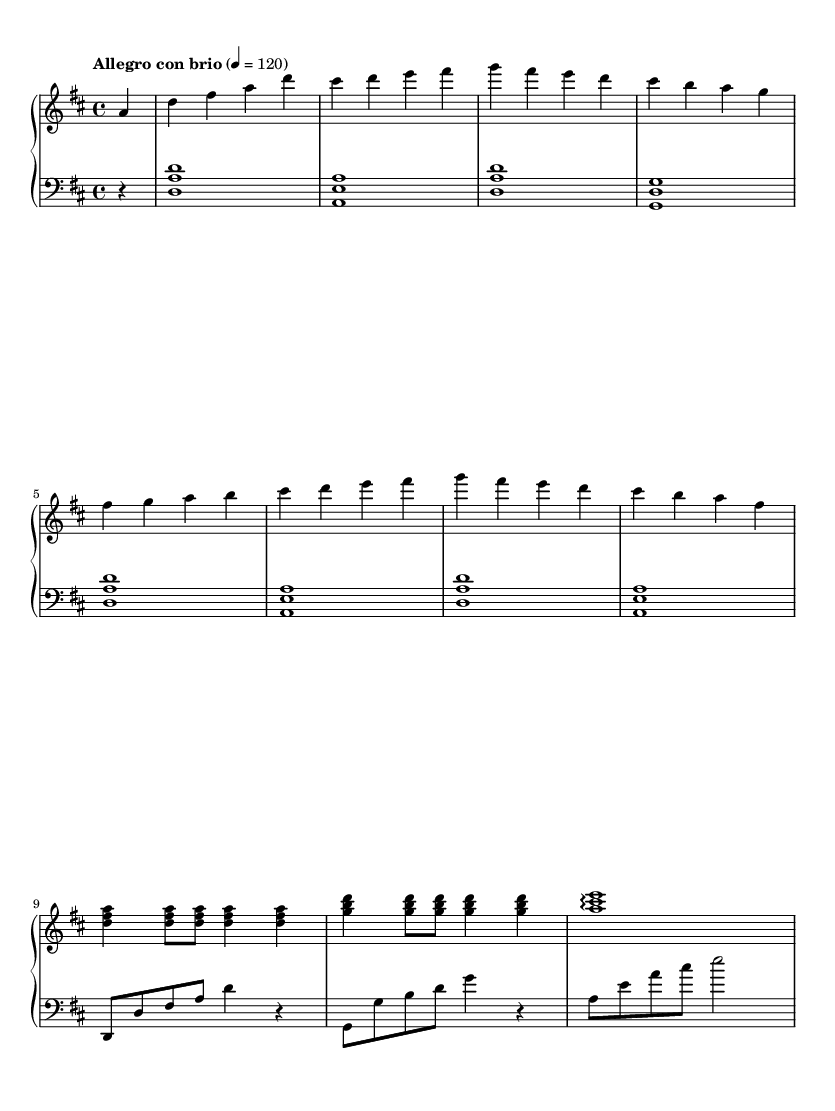What is the key signature of this music? The key signature is D major, which has two sharps (F# and C#). This is identified by looking at the key signature at the beginning of the piece.
Answer: D major What is the time signature of this music? The time signature is 4/4, which indicates that there are four beats in each measure and the quarter note receives one beat. This can be seen at the beginning of the music notation.
Answer: 4/4 What is the tempo marking for this piece? The tempo marking is "Allegro con brio", indicating a lively and vigorous pace. This is indicated next to the tempo instruction at the start of the piece.
Answer: Allegro con brio How many measures are in the right-hand part? There are 9 measures in the right-hand part. This can be determined by counting the individual sections defined by bar lines in the right-hand staff.
Answer: 9 What is the first note in the left-hand part? The first note in the left-hand part is D. This can be found by looking at the initial note in the left staff, which is positioned on the third line of the bass clef.
Answer: D Which clef is used for the left-hand part? The left-hand part uses the bass clef. This is indicated at the beginning of the left-hand staff notation, which is distinct from the treble clef used for the right-hand part.
Answer: Bass clef 